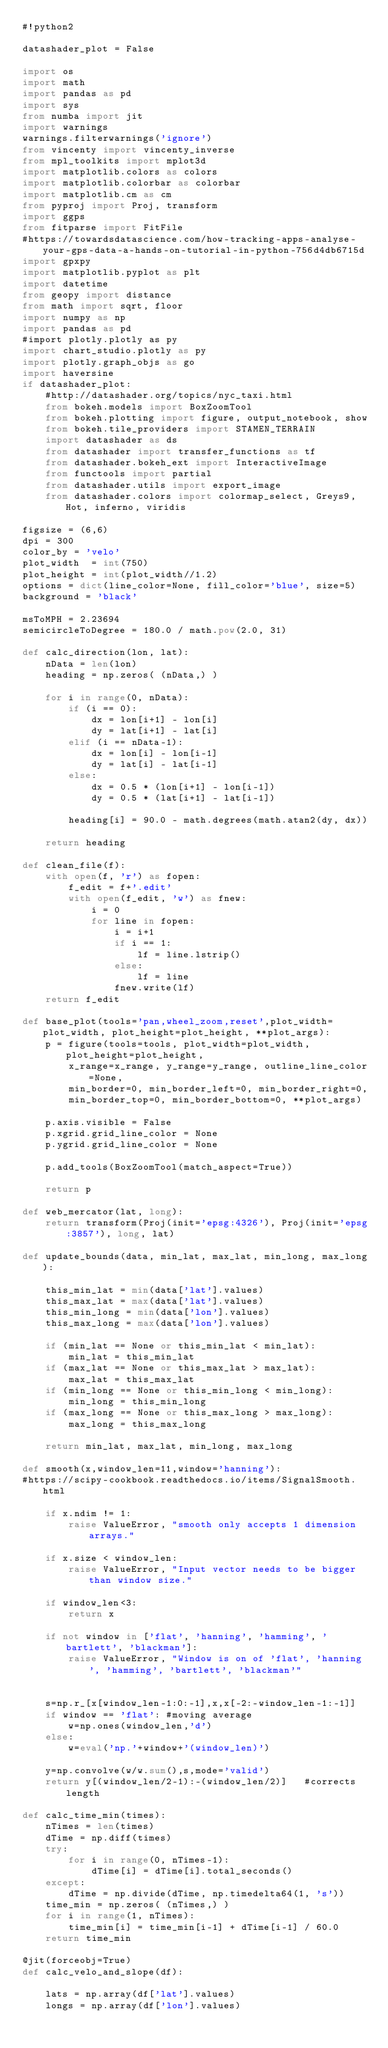<code> <loc_0><loc_0><loc_500><loc_500><_Python_>#!python2

datashader_plot = False

import os
import math
import pandas as pd
import sys
from numba import jit
import warnings
warnings.filterwarnings('ignore')
from vincenty import vincenty_inverse
from mpl_toolkits import mplot3d
import matplotlib.colors as colors
import matplotlib.colorbar as colorbar
import matplotlib.cm as cm
from pyproj import Proj, transform
import ggps
from fitparse import FitFile
#https://towardsdatascience.com/how-tracking-apps-analyse-your-gps-data-a-hands-on-tutorial-in-python-756d4db6715d
import gpxpy
import matplotlib.pyplot as plt
import datetime
from geopy import distance
from math import sqrt, floor
import numpy as np
import pandas as pd
#import plotly.plotly as py
import chart_studio.plotly as py
import plotly.graph_objs as go
import haversine
if datashader_plot:
    #http://datashader.org/topics/nyc_taxi.html
    from bokeh.models import BoxZoomTool
    from bokeh.plotting import figure, output_notebook, show
    from bokeh.tile_providers import STAMEN_TERRAIN
    import datashader as ds
    from datashader import transfer_functions as tf
    from datashader.bokeh_ext import InteractiveImage
    from functools import partial
    from datashader.utils import export_image
    from datashader.colors import colormap_select, Greys9, Hot, inferno, viridis

figsize = (6,6)
dpi = 300
color_by = 'velo'
plot_width  = int(750)
plot_height = int(plot_width//1.2)
options = dict(line_color=None, fill_color='blue', size=5)
background = 'black'

msToMPH = 2.23694
semicircleToDegree = 180.0 / math.pow(2.0, 31)

def calc_direction(lon, lat):
    nData = len(lon)
    heading = np.zeros( (nData,) )

    for i in range(0, nData):
        if (i == 0):
            dx = lon[i+1] - lon[i]
            dy = lat[i+1] - lat[i]
        elif (i == nData-1):
            dx = lon[i] - lon[i-1]
            dy = lat[i] - lat[i-1]
        else:
            dx = 0.5 * (lon[i+1] - lon[i-1])
            dy = 0.5 * (lat[i+1] - lat[i-1])

        heading[i] = 90.0 - math.degrees(math.atan2(dy, dx))

    return heading

def clean_file(f):
    with open(f, 'r') as fopen:
        f_edit = f+'.edit'
        with open(f_edit, 'w') as fnew:
            i = 0
            for line in fopen:
                i = i+1
                if i == 1:
                    lf = line.lstrip()
                else:
                    lf = line
                fnew.write(lf)
    return f_edit

def base_plot(tools='pan,wheel_zoom,reset',plot_width=plot_width, plot_height=plot_height, **plot_args):
    p = figure(tools=tools, plot_width=plot_width, plot_height=plot_height,
        x_range=x_range, y_range=y_range, outline_line_color=None,
        min_border=0, min_border_left=0, min_border_right=0,
        min_border_top=0, min_border_bottom=0, **plot_args)

    p.axis.visible = False
    p.xgrid.grid_line_color = None
    p.ygrid.grid_line_color = None

    p.add_tools(BoxZoomTool(match_aspect=True))

    return p

def web_mercator(lat, long):
    return transform(Proj(init='epsg:4326'), Proj(init='epsg:3857'), long, lat)

def update_bounds(data, min_lat, max_lat, min_long, max_long):

    this_min_lat = min(data['lat'].values)
    this_max_lat = max(data['lat'].values)
    this_min_long = min(data['lon'].values)
    this_max_long = max(data['lon'].values)

    if (min_lat == None or this_min_lat < min_lat):
        min_lat = this_min_lat
    if (max_lat == None or this_max_lat > max_lat):
        max_lat = this_max_lat
    if (min_long == None or this_min_long < min_long):
        min_long = this_min_long
    if (max_long == None or this_max_long > max_long):
        max_long = this_max_long

    return min_lat, max_lat, min_long, max_long

def smooth(x,window_len=11,window='hanning'):
#https://scipy-cookbook.readthedocs.io/items/SignalSmooth.html

    if x.ndim != 1:
        raise ValueError, "smooth only accepts 1 dimension arrays."

    if x.size < window_len:
        raise ValueError, "Input vector needs to be bigger than window size."

    if window_len<3:
        return x

    if not window in ['flat', 'hanning', 'hamming', 'bartlett', 'blackman']:
        raise ValueError, "Window is on of 'flat', 'hanning', 'hamming', 'bartlett', 'blackman'"


    s=np.r_[x[window_len-1:0:-1],x,x[-2:-window_len-1:-1]]
    if window == 'flat': #moving average
        w=np.ones(window_len,'d')
    else:
        w=eval('np.'+window+'(window_len)')

    y=np.convolve(w/w.sum(),s,mode='valid')
    return y[(window_len/2-1):-(window_len/2)]   #corrects length

def calc_time_min(times):
    nTimes = len(times)
    dTime = np.diff(times)
    try:
        for i in range(0, nTimes-1):
            dTime[i] = dTime[i].total_seconds()
    except:
        dTime = np.divide(dTime, np.timedelta64(1, 's'))
    time_min = np.zeros( (nTimes,) ) 
    for i in range(1, nTimes):
        time_min[i] = time_min[i-1] + dTime[i-1] / 60.0
    return time_min

@jit(forceobj=True)
def calc_velo_and_slope(df):

    lats = np.array(df['lat'].values)  
    longs = np.array(df['lon'].values)</code> 